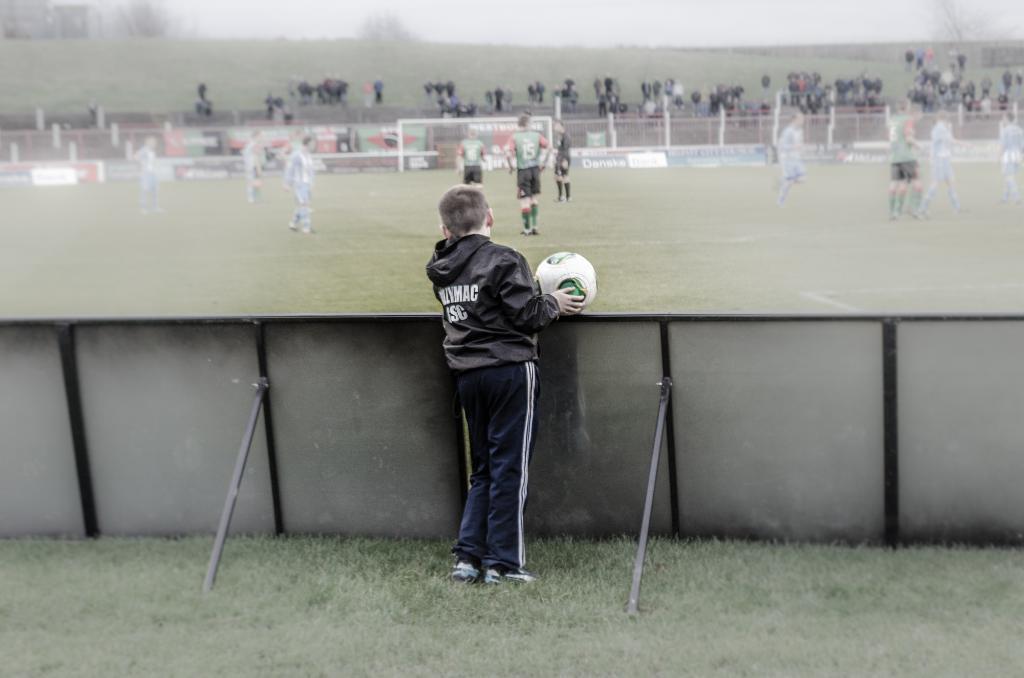Could you give a brief overview of what you see in this image? Here in the front we can see a boy with football in his hand standing behind the barricades and there are group of people playing football in the ground 